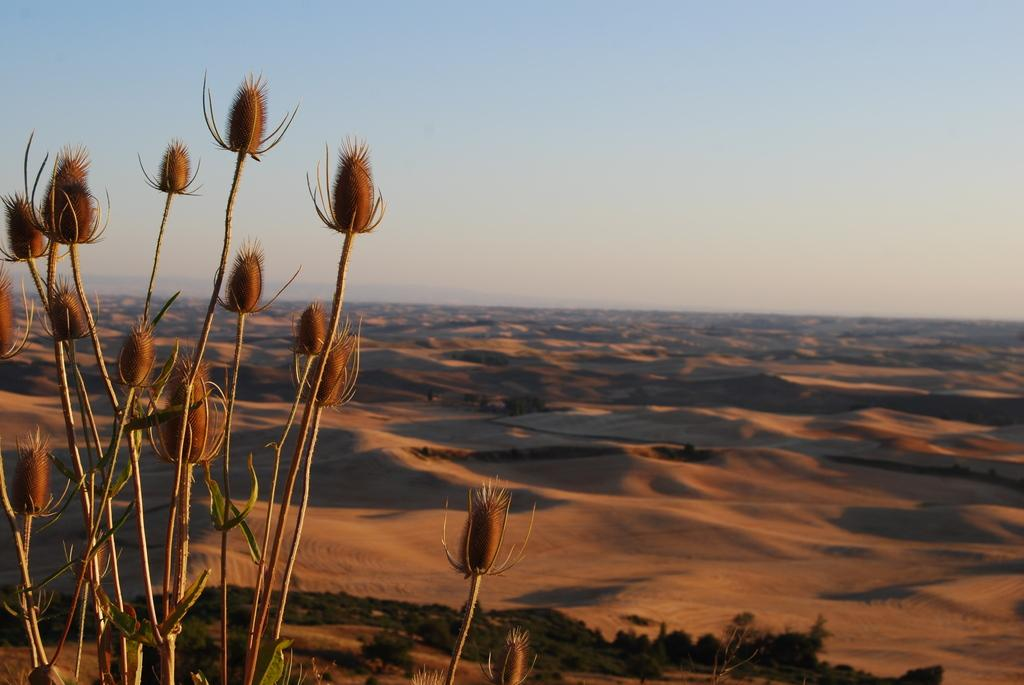What type of environment might the image be depicting? The image might be taken at a desert. What can be seen in the center of the image? There are plants in the center of the image. What type of terrain is visible in the background of the image? There is sand visible in the background of the image. What else is visible in the background of the image? The sky is visible in the background of the image. What type of drink is being served in the image? There is no drink visible in the image; it primarily features plants, sand, and the sky. What type of educational setting is depicted in the image? There is no educational setting or class present in the image. 